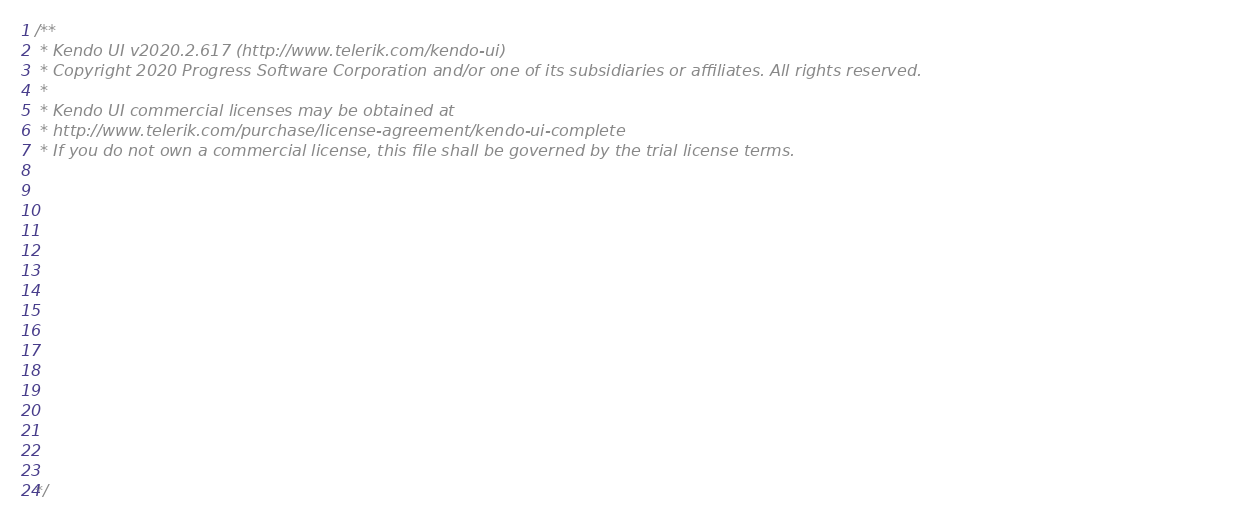<code> <loc_0><loc_0><loc_500><loc_500><_JavaScript_>/** 
 * Kendo UI v2020.2.617 (http://www.telerik.com/kendo-ui)                                                                                                                                               
 * Copyright 2020 Progress Software Corporation and/or one of its subsidiaries or affiliates. All rights reserved.                                                                                      
 *                                                                                                                                                                                                      
 * Kendo UI commercial licenses may be obtained at                                                                                                                                                      
 * http://www.telerik.com/purchase/license-agreement/kendo-ui-complete                                                                                                                                  
 * If you do not own a commercial license, this file shall be governed by the trial license terms.                                                                                                      
                                                                                                                                                                                                       
                                                                                                                                                                                                       
                                                                                                                                                                                                       
                                                                                                                                                                                                       
                                                                                                                                                                                                       
                                                                                                                                                                                                       
                                                                                                                                                                                                       
                                                                                                                                                                                                       
                                                                                                                                                                                                       
                                                                                                                                                                                                       
                                                                                                                                                                                                       
                                                                                                                                                                                                       
                                                                                                                                                                                                       
                                                                                                                                                                                                       
                                                                                                                                                                                                       

*/</code> 